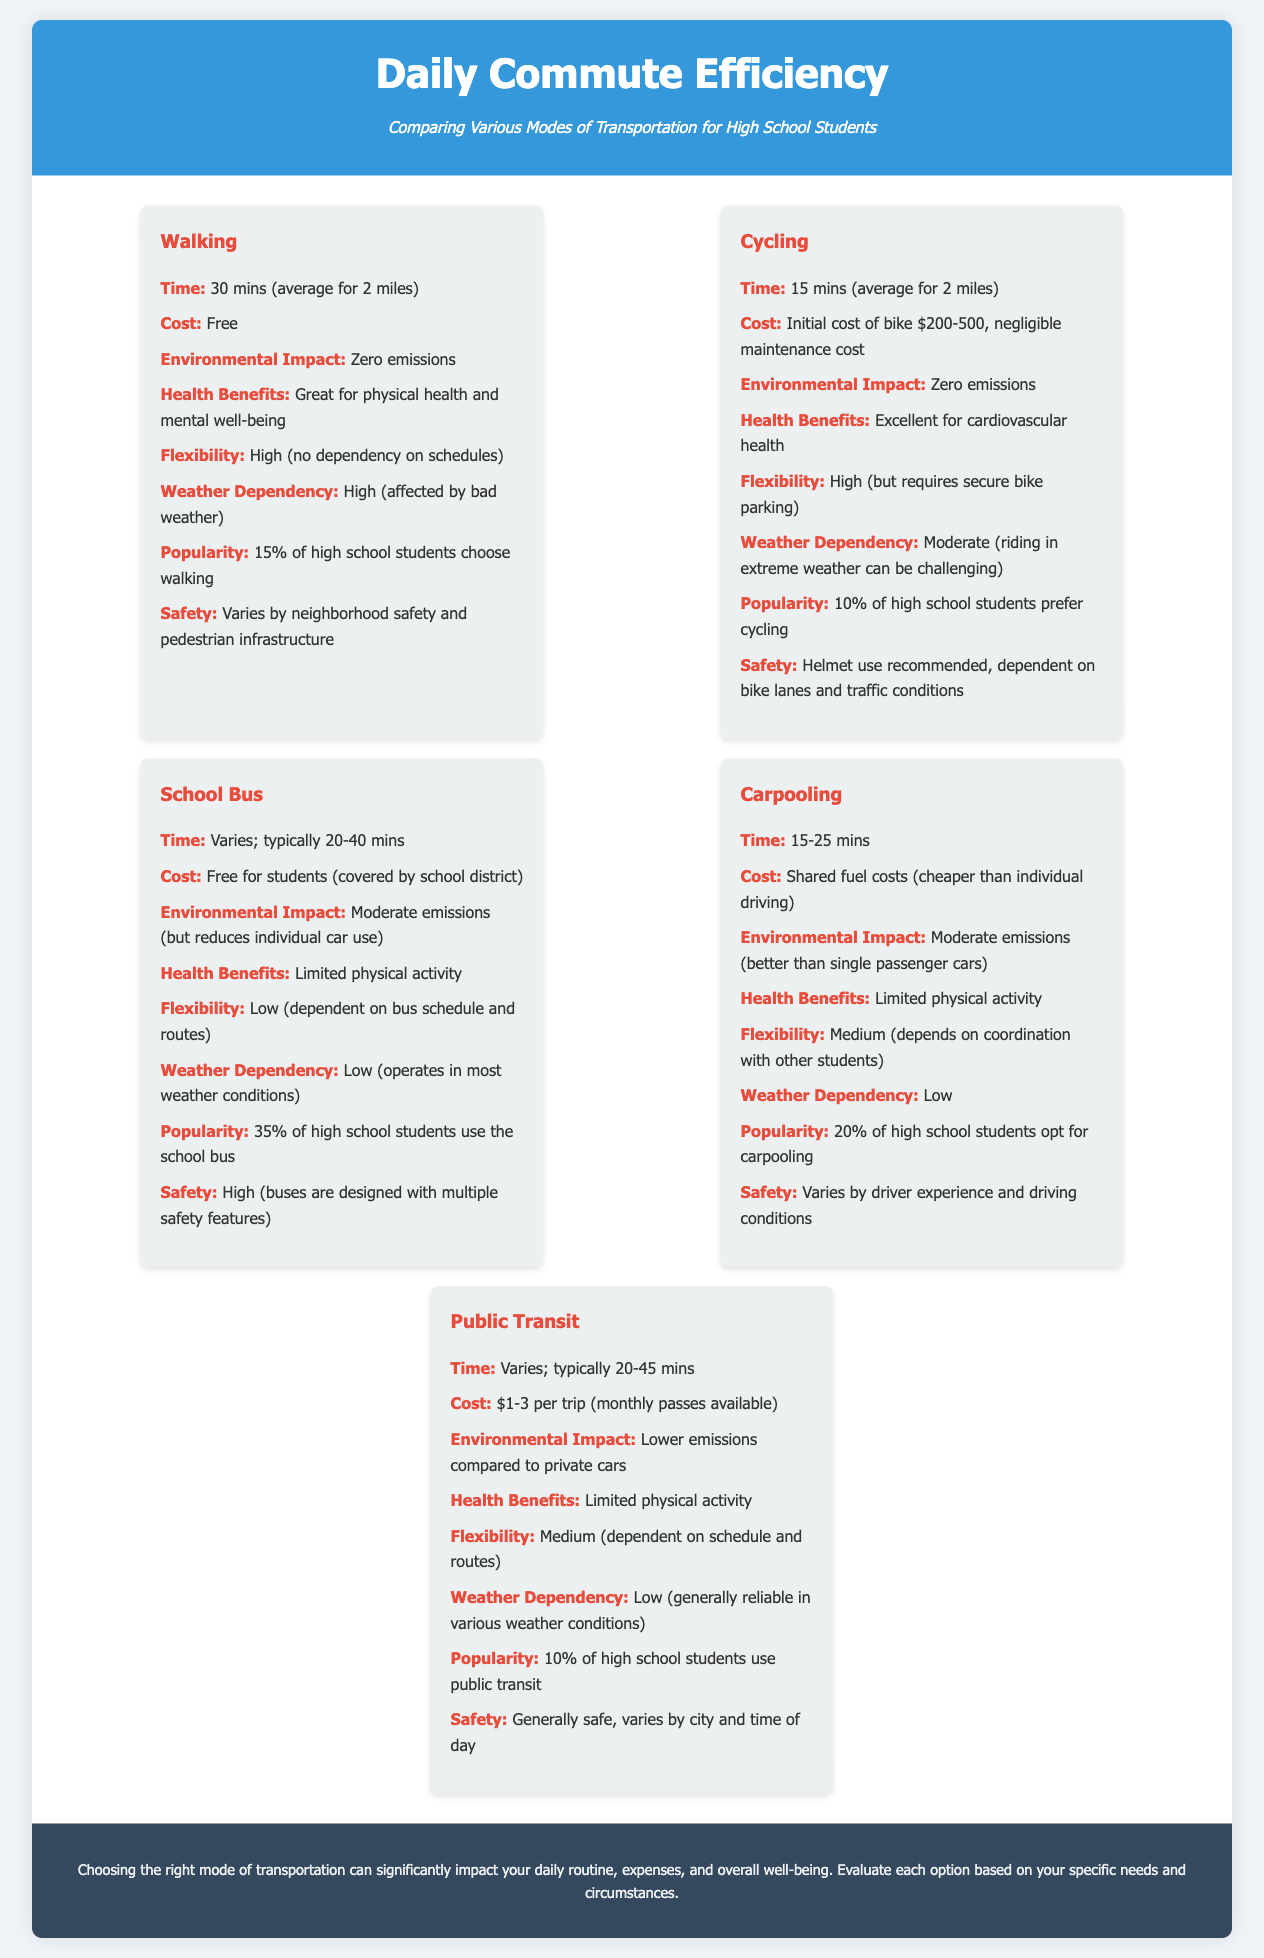What is the average time it takes to walk to school? The average time for walking to school is stated in the document as 30 mins for 2 miles.
Answer: 30 mins What is the cost of using the school bus? The cost for students using the school bus is mentioned as free, covered by the school district.
Answer: Free Which mode of transportation has a popularity of 15% among high school students? The document identifies walking as the mode of transportation with a 15% popularity rate.
Answer: Walking What is the environmental impact of cycling? The document states that cycling has zero emissions as its environmental impact.
Answer: Zero emissions Which mode has the highest flexibility? Walking is noted as having high flexibility since there is no dependency on schedules.
Answer: Walking What is the safety rating for public transit? The document indicates that public transit is generally safe, though it varies by city and time of day.
Answer: Generally safe What is the typical time range for carpooling? The time range for carpooling is provided in the document as 15-25 mins.
Answer: 15-25 mins How much does public transit cost per trip? The cost for public transit per trip is specified as $1-3.
Answer: $1-3 What is the health benefit of cycling mentioned in the document? The document notes that cycling is excellent for cardiovascular health as a health benefit.
Answer: Excellent for cardiovascular health 